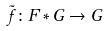<formula> <loc_0><loc_0><loc_500><loc_500>\tilde { f } \colon F * G \rightarrow G</formula> 